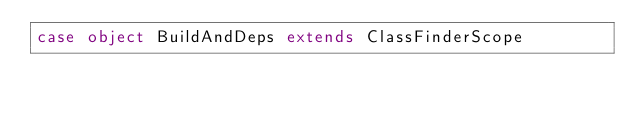<code> <loc_0><loc_0><loc_500><loc_500><_Scala_>case object BuildAndDeps extends ClassFinderScope
</code> 